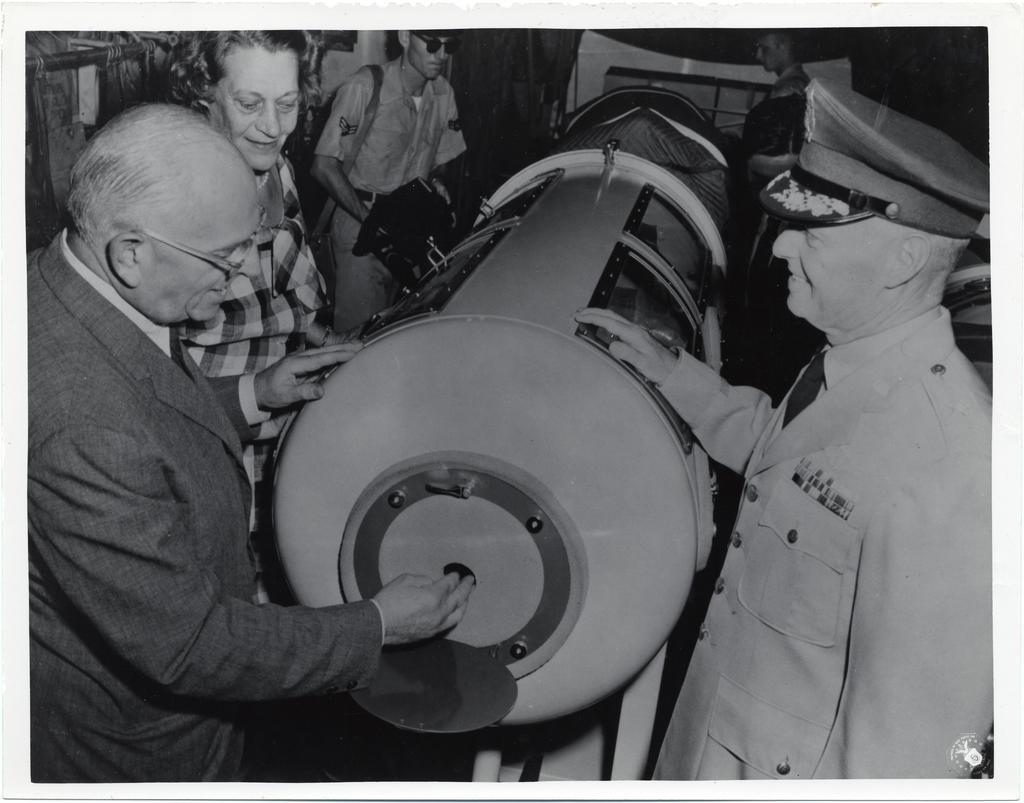What is the main subject in the center of the image? There is a machine in the center of the image. What are the people doing in the image? The people are standing around the machine. Can you describe the appearance of one of the individuals? A man standing on the right side of the machine is wearing a cap. What type of crook can be seen in the image? There is no crook present in the image. Can you tell me how the guide is assisting the people in the image? There is no guide present in the image. 